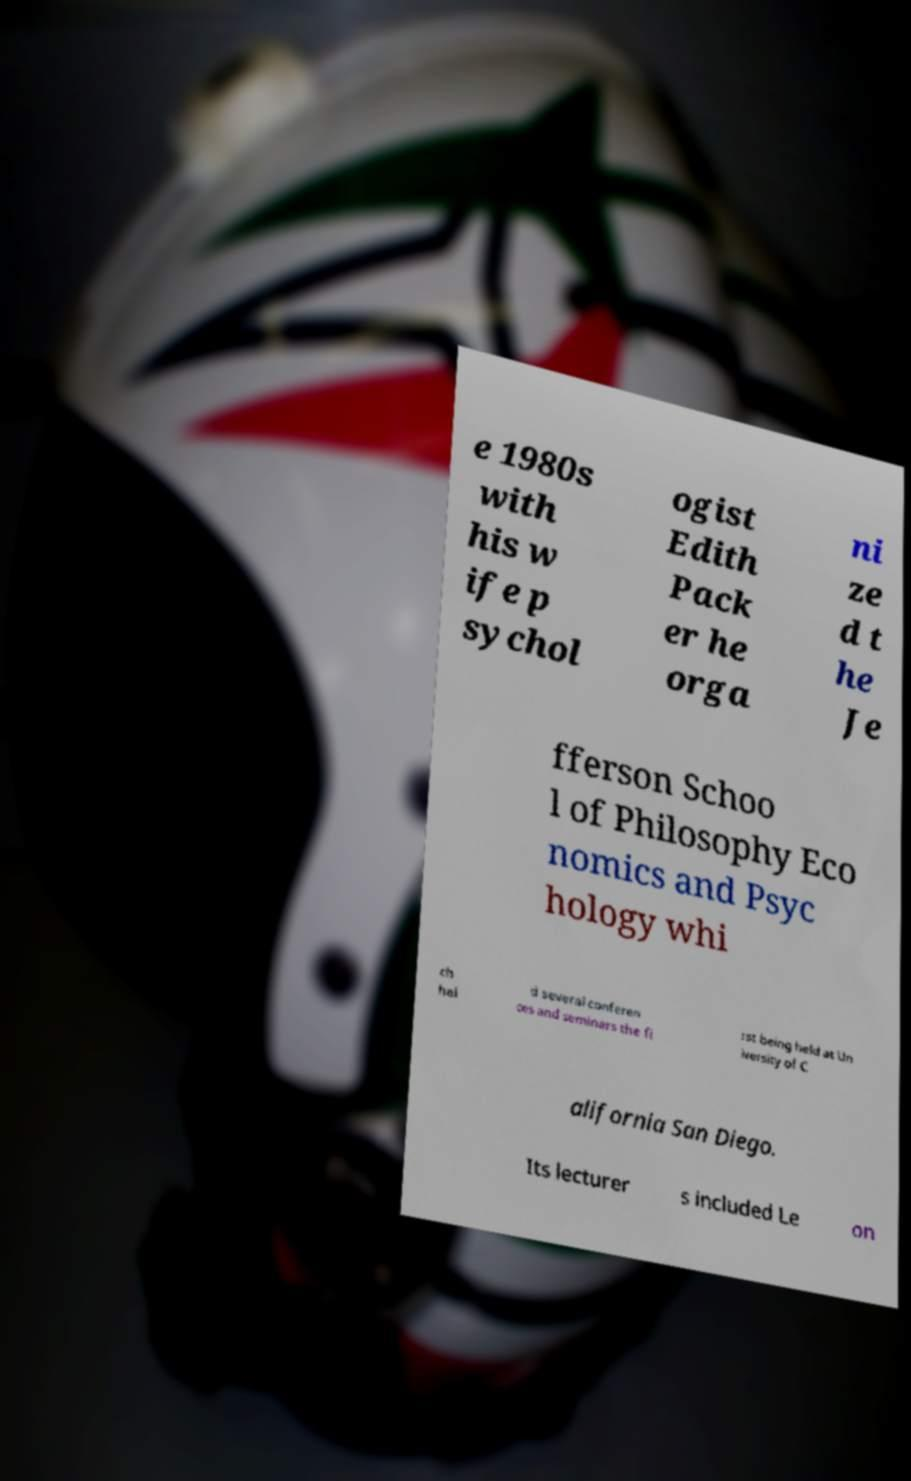Please identify and transcribe the text found in this image. e 1980s with his w ife p sychol ogist Edith Pack er he orga ni ze d t he Je fferson Schoo l of Philosophy Eco nomics and Psyc hology whi ch hel d several conferen ces and seminars the fi rst being held at Un iversity of C alifornia San Diego. Its lecturer s included Le on 